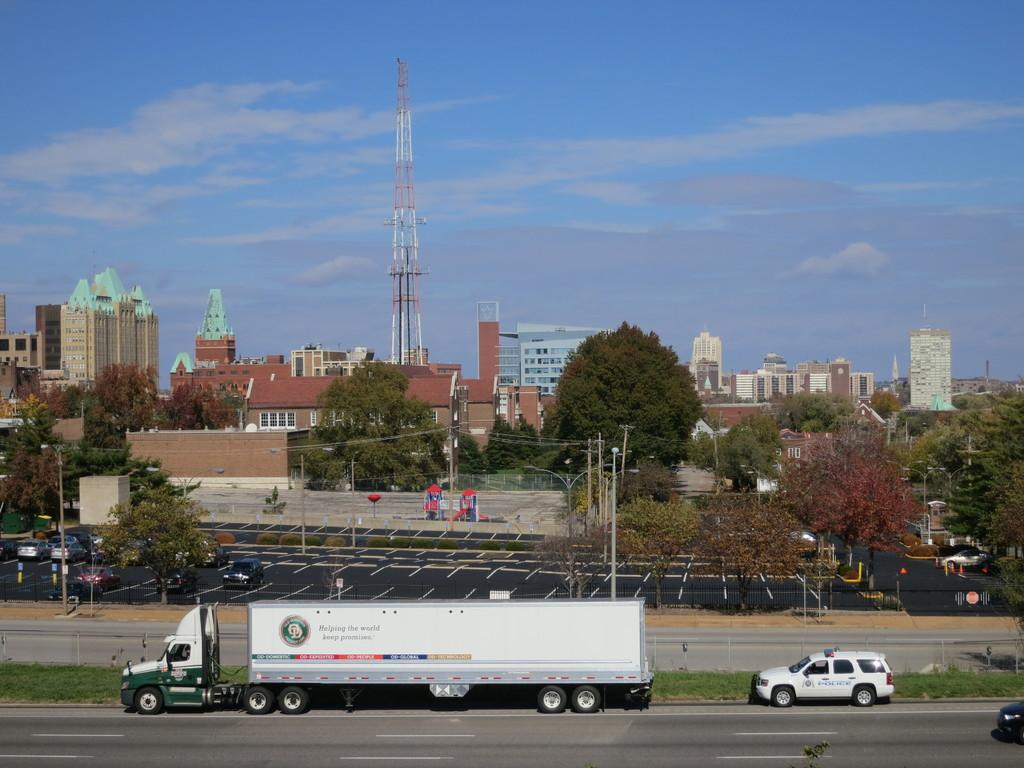What can be seen on the road in the image? There are vehicles on the road in the image. What structures are present in the image? There are poles, a tower, boards, and buildings in the image. What natural elements can be seen in the image? There are trees and clouds in the sky in the image. What objects are visible in the image? There are wires, objects, and windows in the image. What type of sock is hanging from the tower in the image? There is no sock present in the image; the tower does not have any clothing items hanging from it. How many apples are visible on the road in the image? There are no apples present in the image; the road only has vehicles on it. 